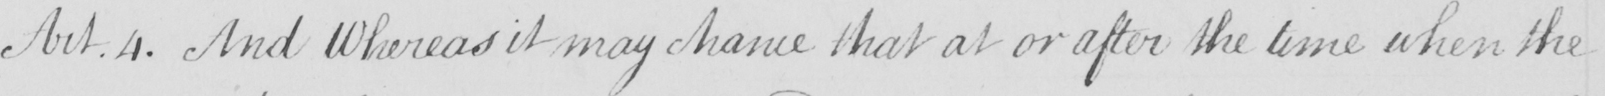Please transcribe the handwritten text in this image. Art.4 . And Whereas it may chance that at or after the time when the 